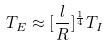Convert formula to latex. <formula><loc_0><loc_0><loc_500><loc_500>T _ { E } \approx [ \frac { l } { R } ] ^ { \frac { 1 } { 4 } } T _ { I }</formula> 